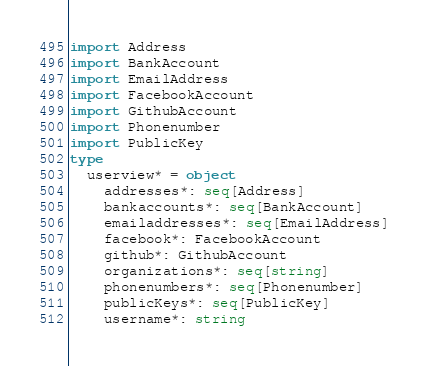<code> <loc_0><loc_0><loc_500><loc_500><_Nim_>
import Address
import BankAccount
import EmailAddress
import FacebookAccount
import GithubAccount
import Phonenumber
import PublicKey
type
  userview* = object
    addresses*: seq[Address]
    bankaccounts*: seq[BankAccount]
    emailaddresses*: seq[EmailAddress]
    facebook*: FacebookAccount
    github*: GithubAccount
    organizations*: seq[string]
    phonenumbers*: seq[Phonenumber]
    publicKeys*: seq[PublicKey]
    username*: string
</code> 